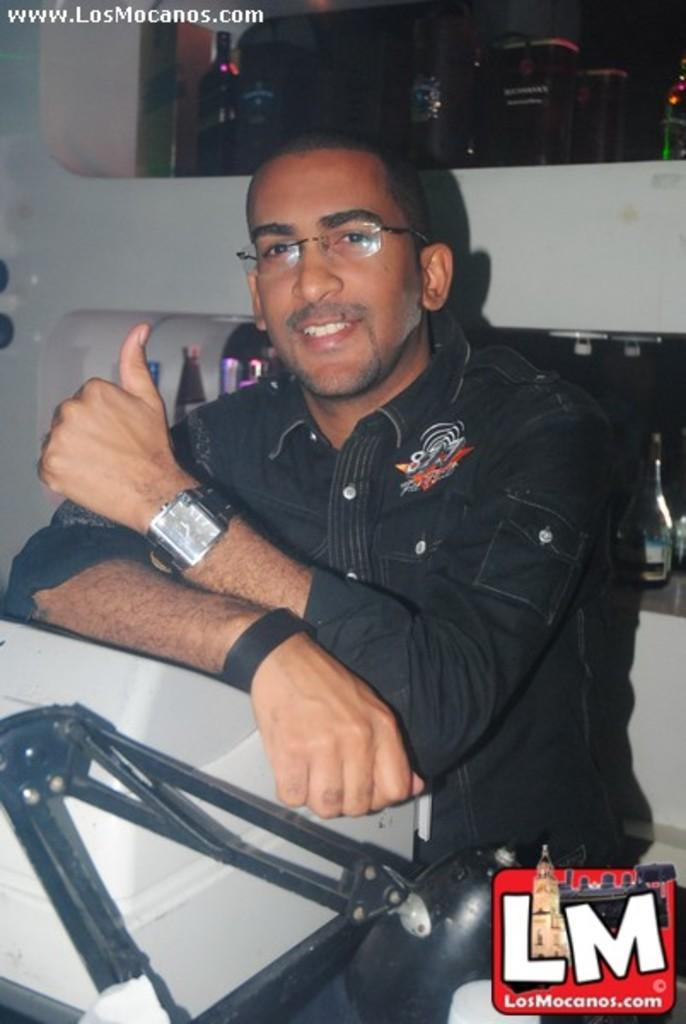What is the man in the image doing? The man is sitting in the image. What accessories is the man wearing? The man is wearing glasses (specs) and a watch. What can be seen in the background of the image? There are bottles in the background of the image. What color is the object in the image? There is a white color object in the image. What type of bread is the man eating in the image? There is no bread present in the image. How does the man's death affect the objects in the image? The image does not depict the man's death, so it cannot be determined how it would affect the objects in the image. 